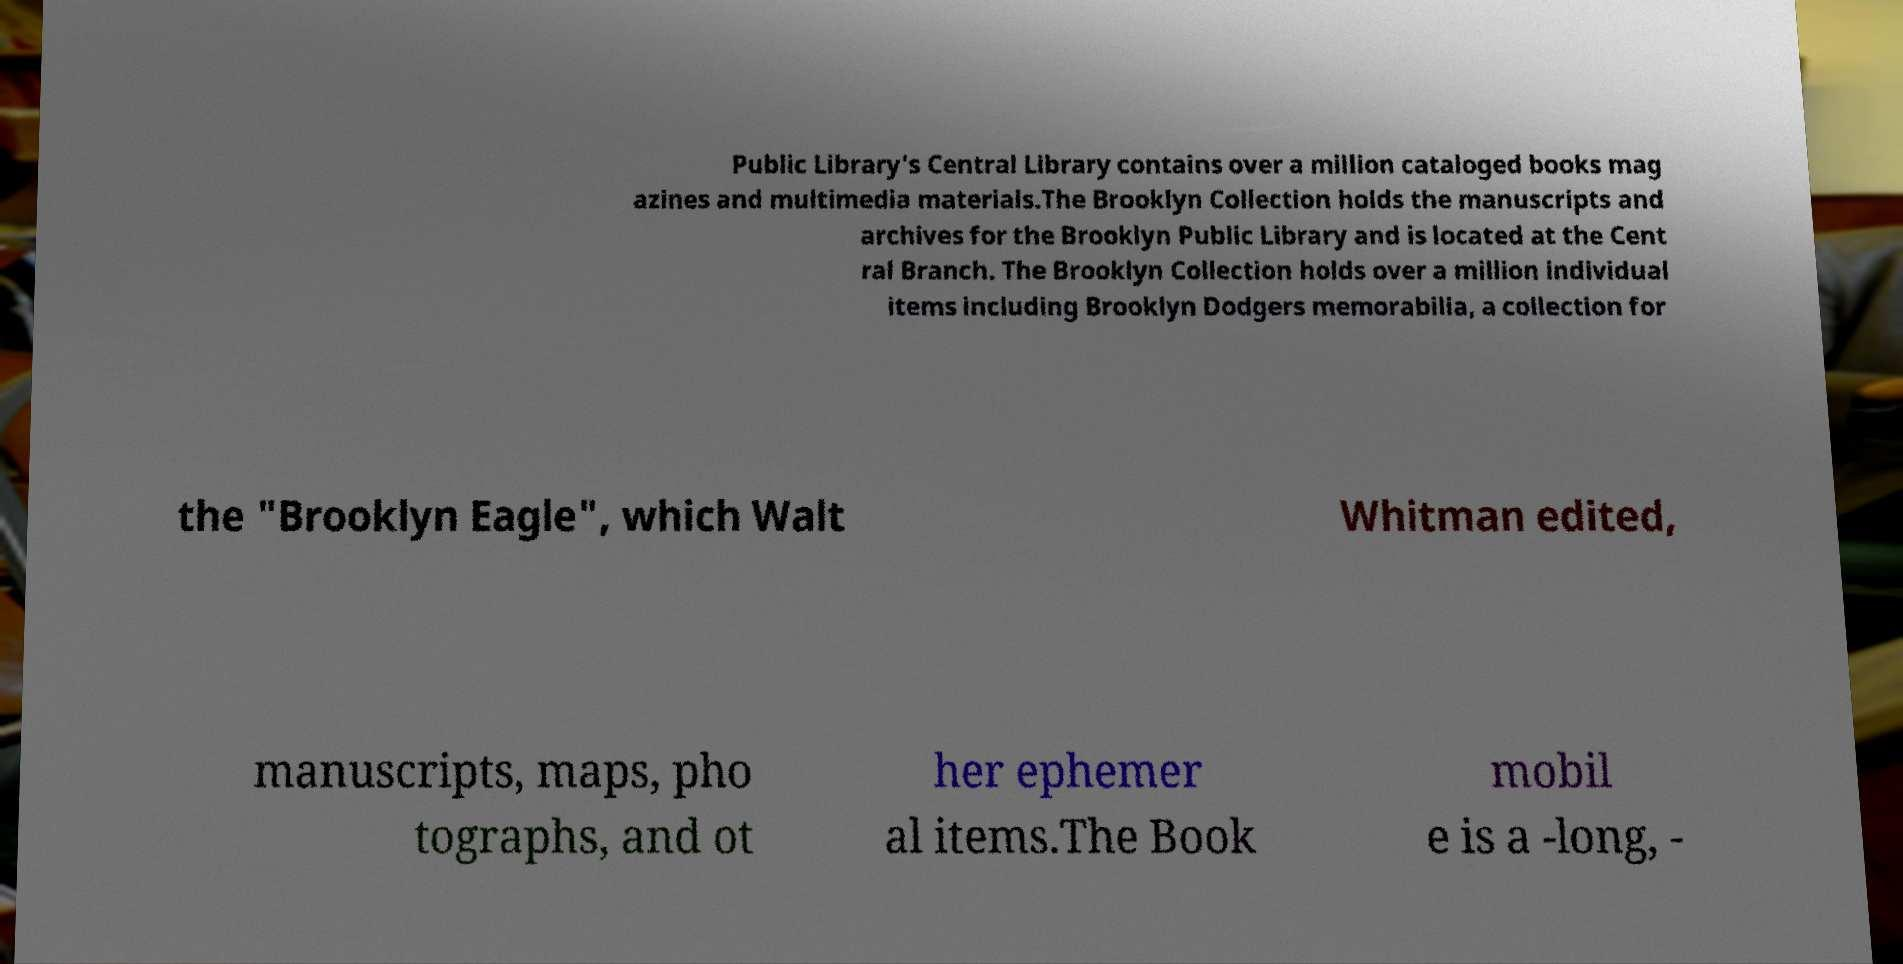What messages or text are displayed in this image? I need them in a readable, typed format. Public Library's Central Library contains over a million cataloged books mag azines and multimedia materials.The Brooklyn Collection holds the manuscripts and archives for the Brooklyn Public Library and is located at the Cent ral Branch. The Brooklyn Collection holds over a million individual items including Brooklyn Dodgers memorabilia, a collection for the "Brooklyn Eagle", which Walt Whitman edited, manuscripts, maps, pho tographs, and ot her ephemer al items.The Book mobil e is a -long, - 